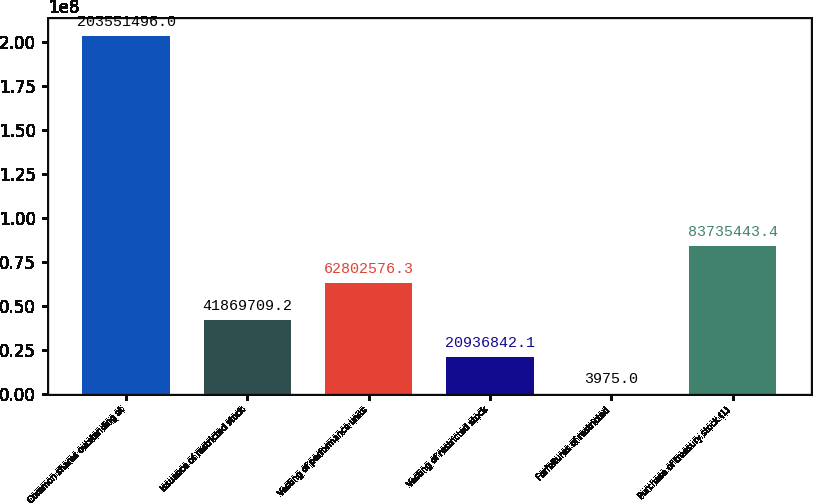Convert chart. <chart><loc_0><loc_0><loc_500><loc_500><bar_chart><fcel>Common shares outstanding at<fcel>Issuance of restricted stock<fcel>Vesting of performance units<fcel>Vesting of restricted stock<fcel>Forfeitures of restricted<fcel>Purchase of treasury stock (1)<nl><fcel>2.03551e+08<fcel>4.18697e+07<fcel>6.28026e+07<fcel>2.09368e+07<fcel>3975<fcel>8.37354e+07<nl></chart> 